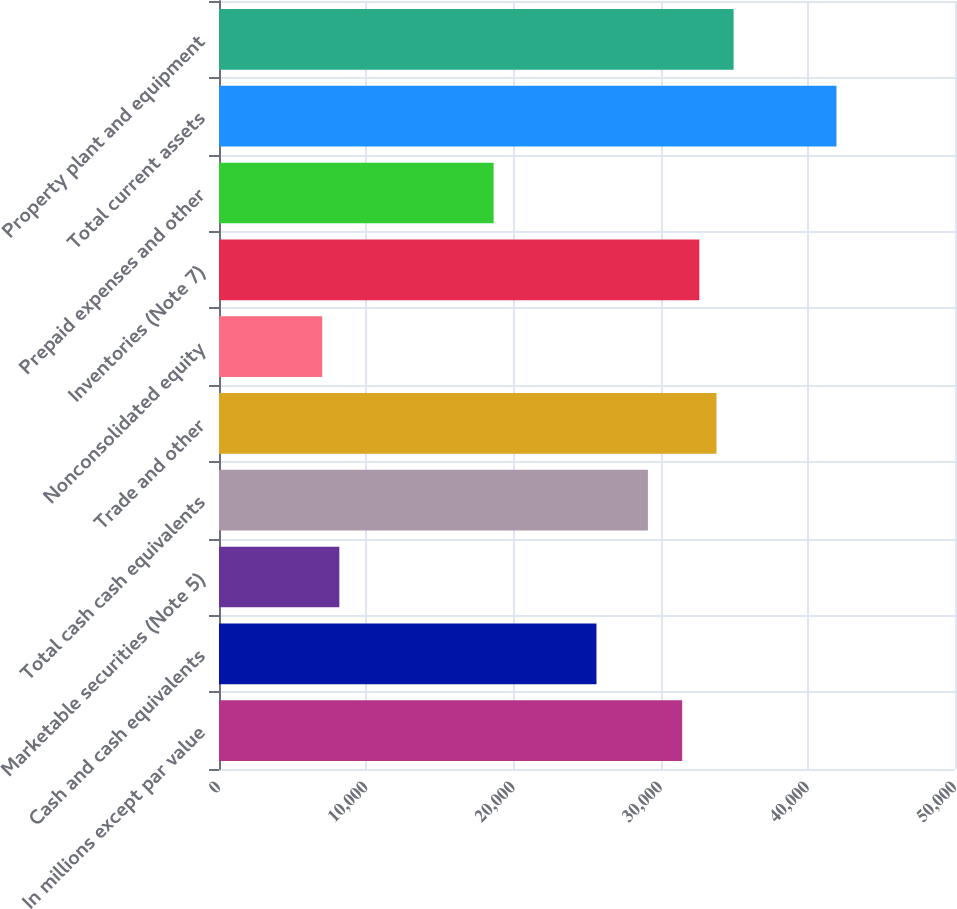Convert chart to OTSL. <chart><loc_0><loc_0><loc_500><loc_500><bar_chart><fcel>In millions except par value<fcel>Cash and cash equivalents<fcel>Marketable securities (Note 5)<fcel>Total cash cash equivalents<fcel>Trade and other<fcel>Nonconsolidated equity<fcel>Inventories (Note 7)<fcel>Prepaid expenses and other<fcel>Total current assets<fcel>Property plant and equipment<nl><fcel>31466.2<fcel>25643.2<fcel>8174.2<fcel>29137<fcel>33795.4<fcel>7009.6<fcel>32630.8<fcel>18655.6<fcel>41947.6<fcel>34960<nl></chart> 